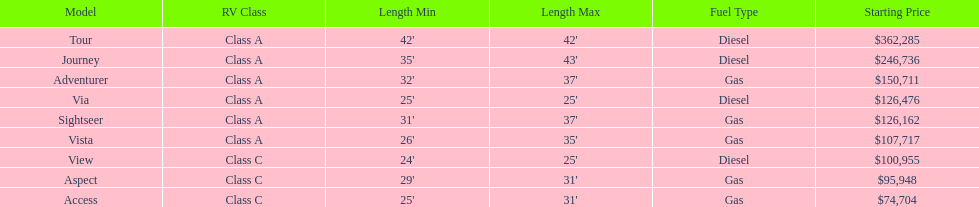How long is the aspect? 29'-31'. 